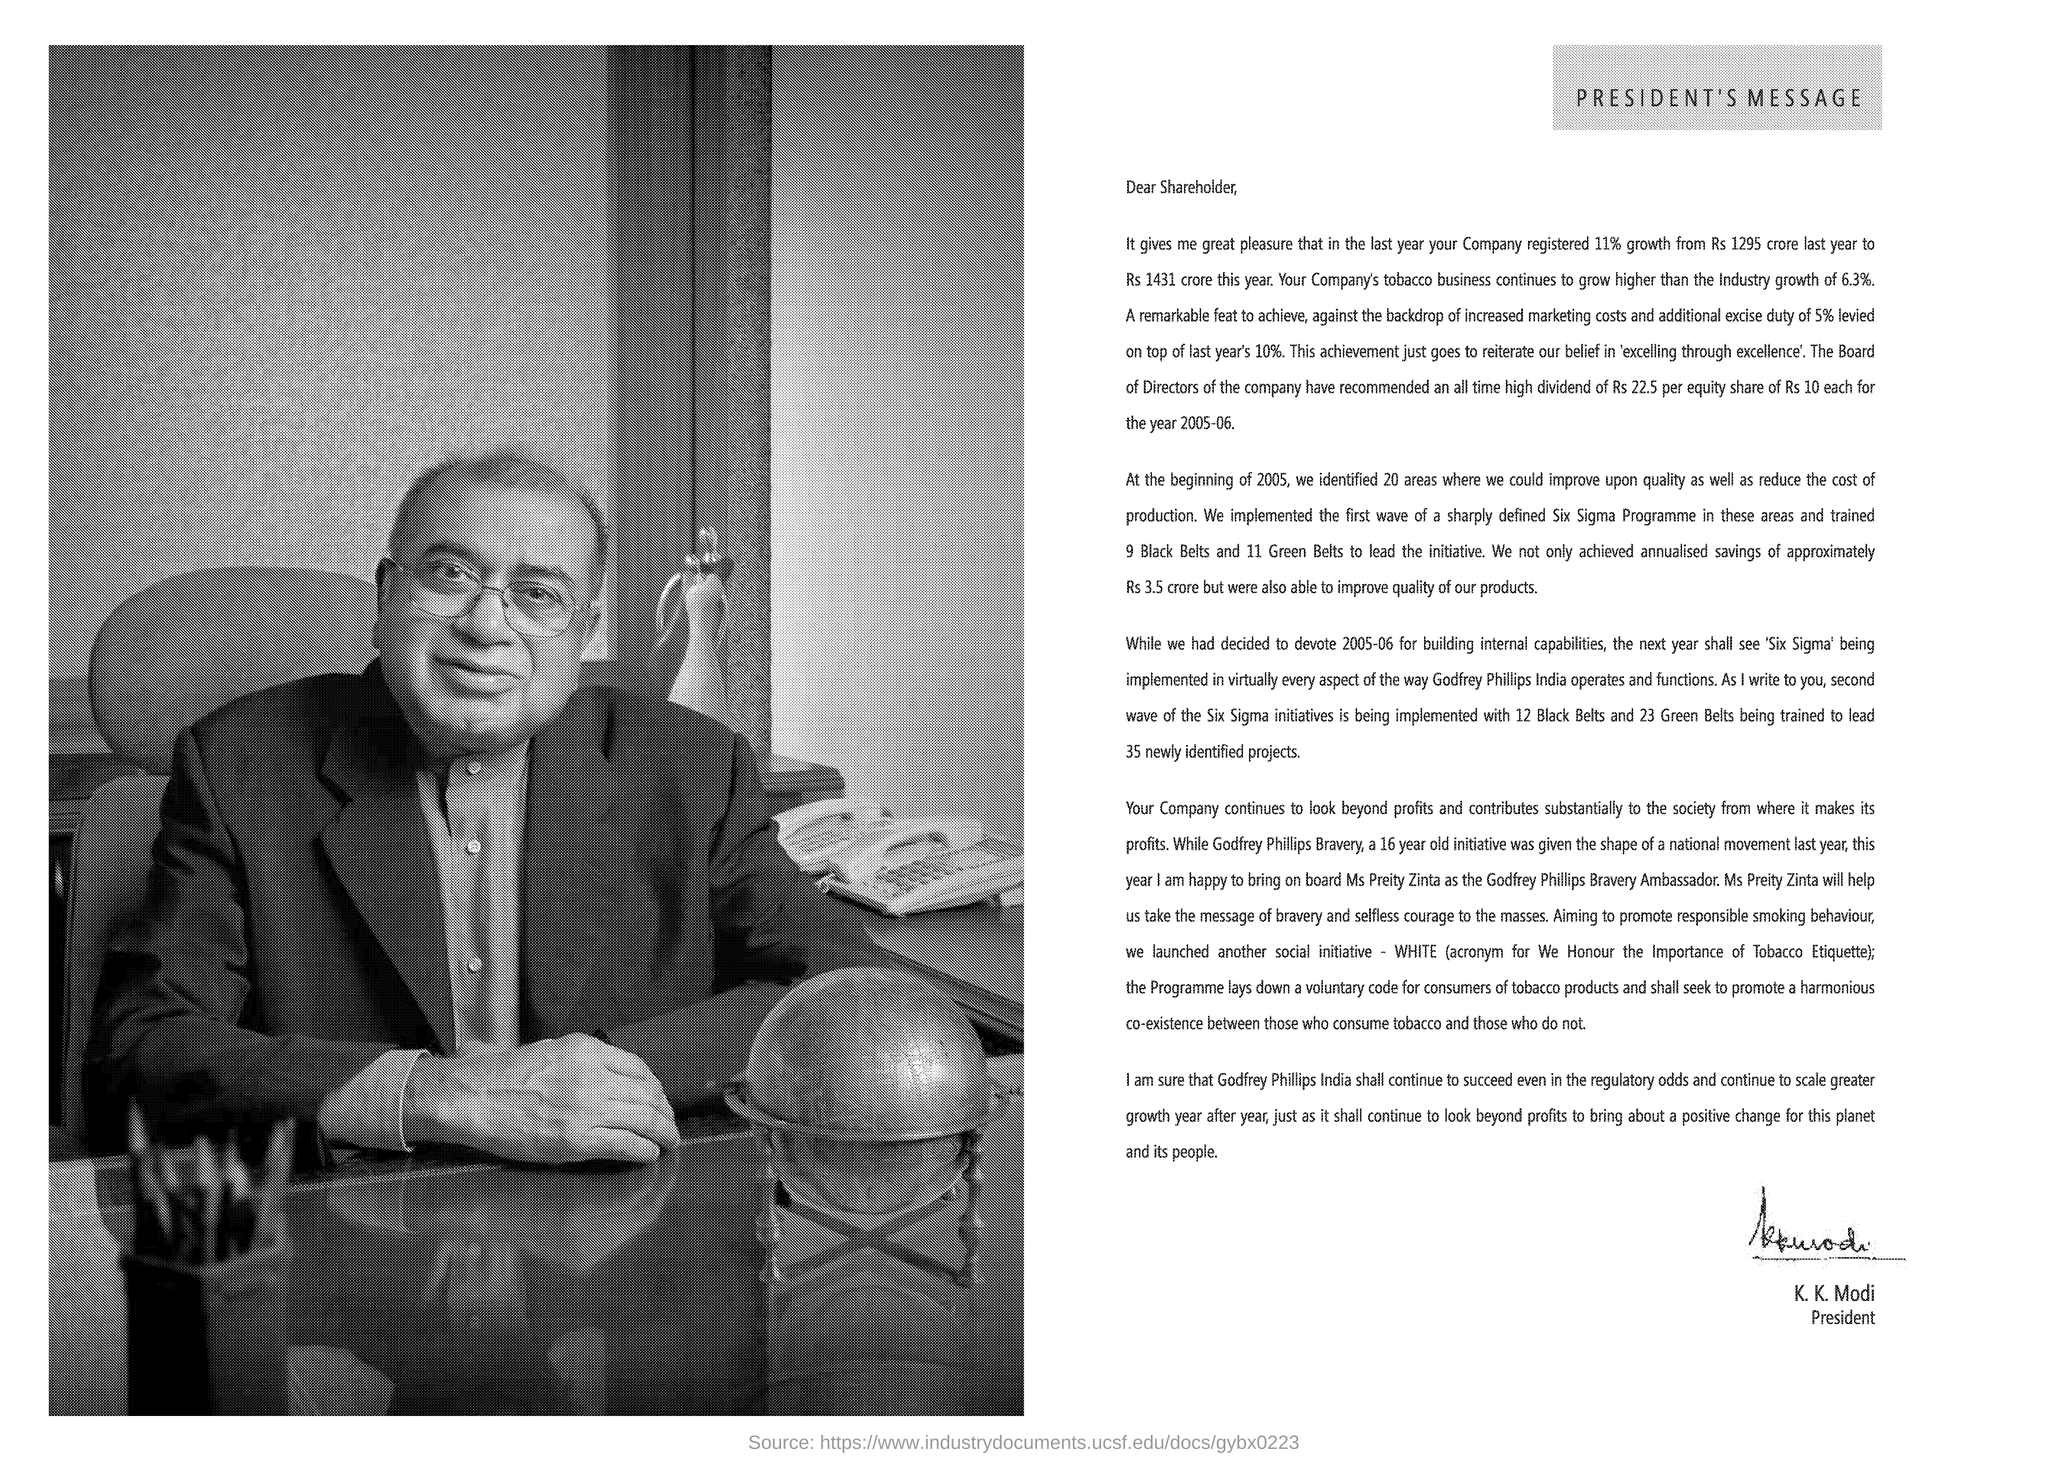Indicate a few pertinent items in this graphic. K. K. Modi is the President. The message is directed to a shareholder. 